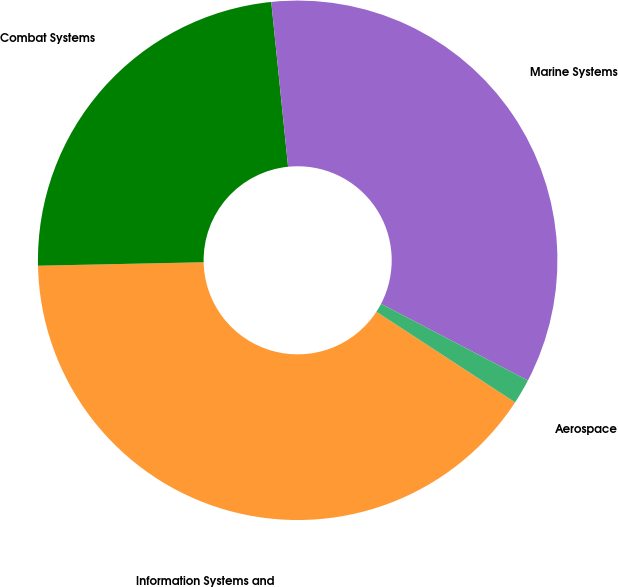Convert chart. <chart><loc_0><loc_0><loc_500><loc_500><pie_chart><fcel>Information Systems and<fcel>Combat Systems<fcel>Marine Systems<fcel>Aerospace<nl><fcel>40.46%<fcel>23.71%<fcel>34.28%<fcel>1.55%<nl></chart> 